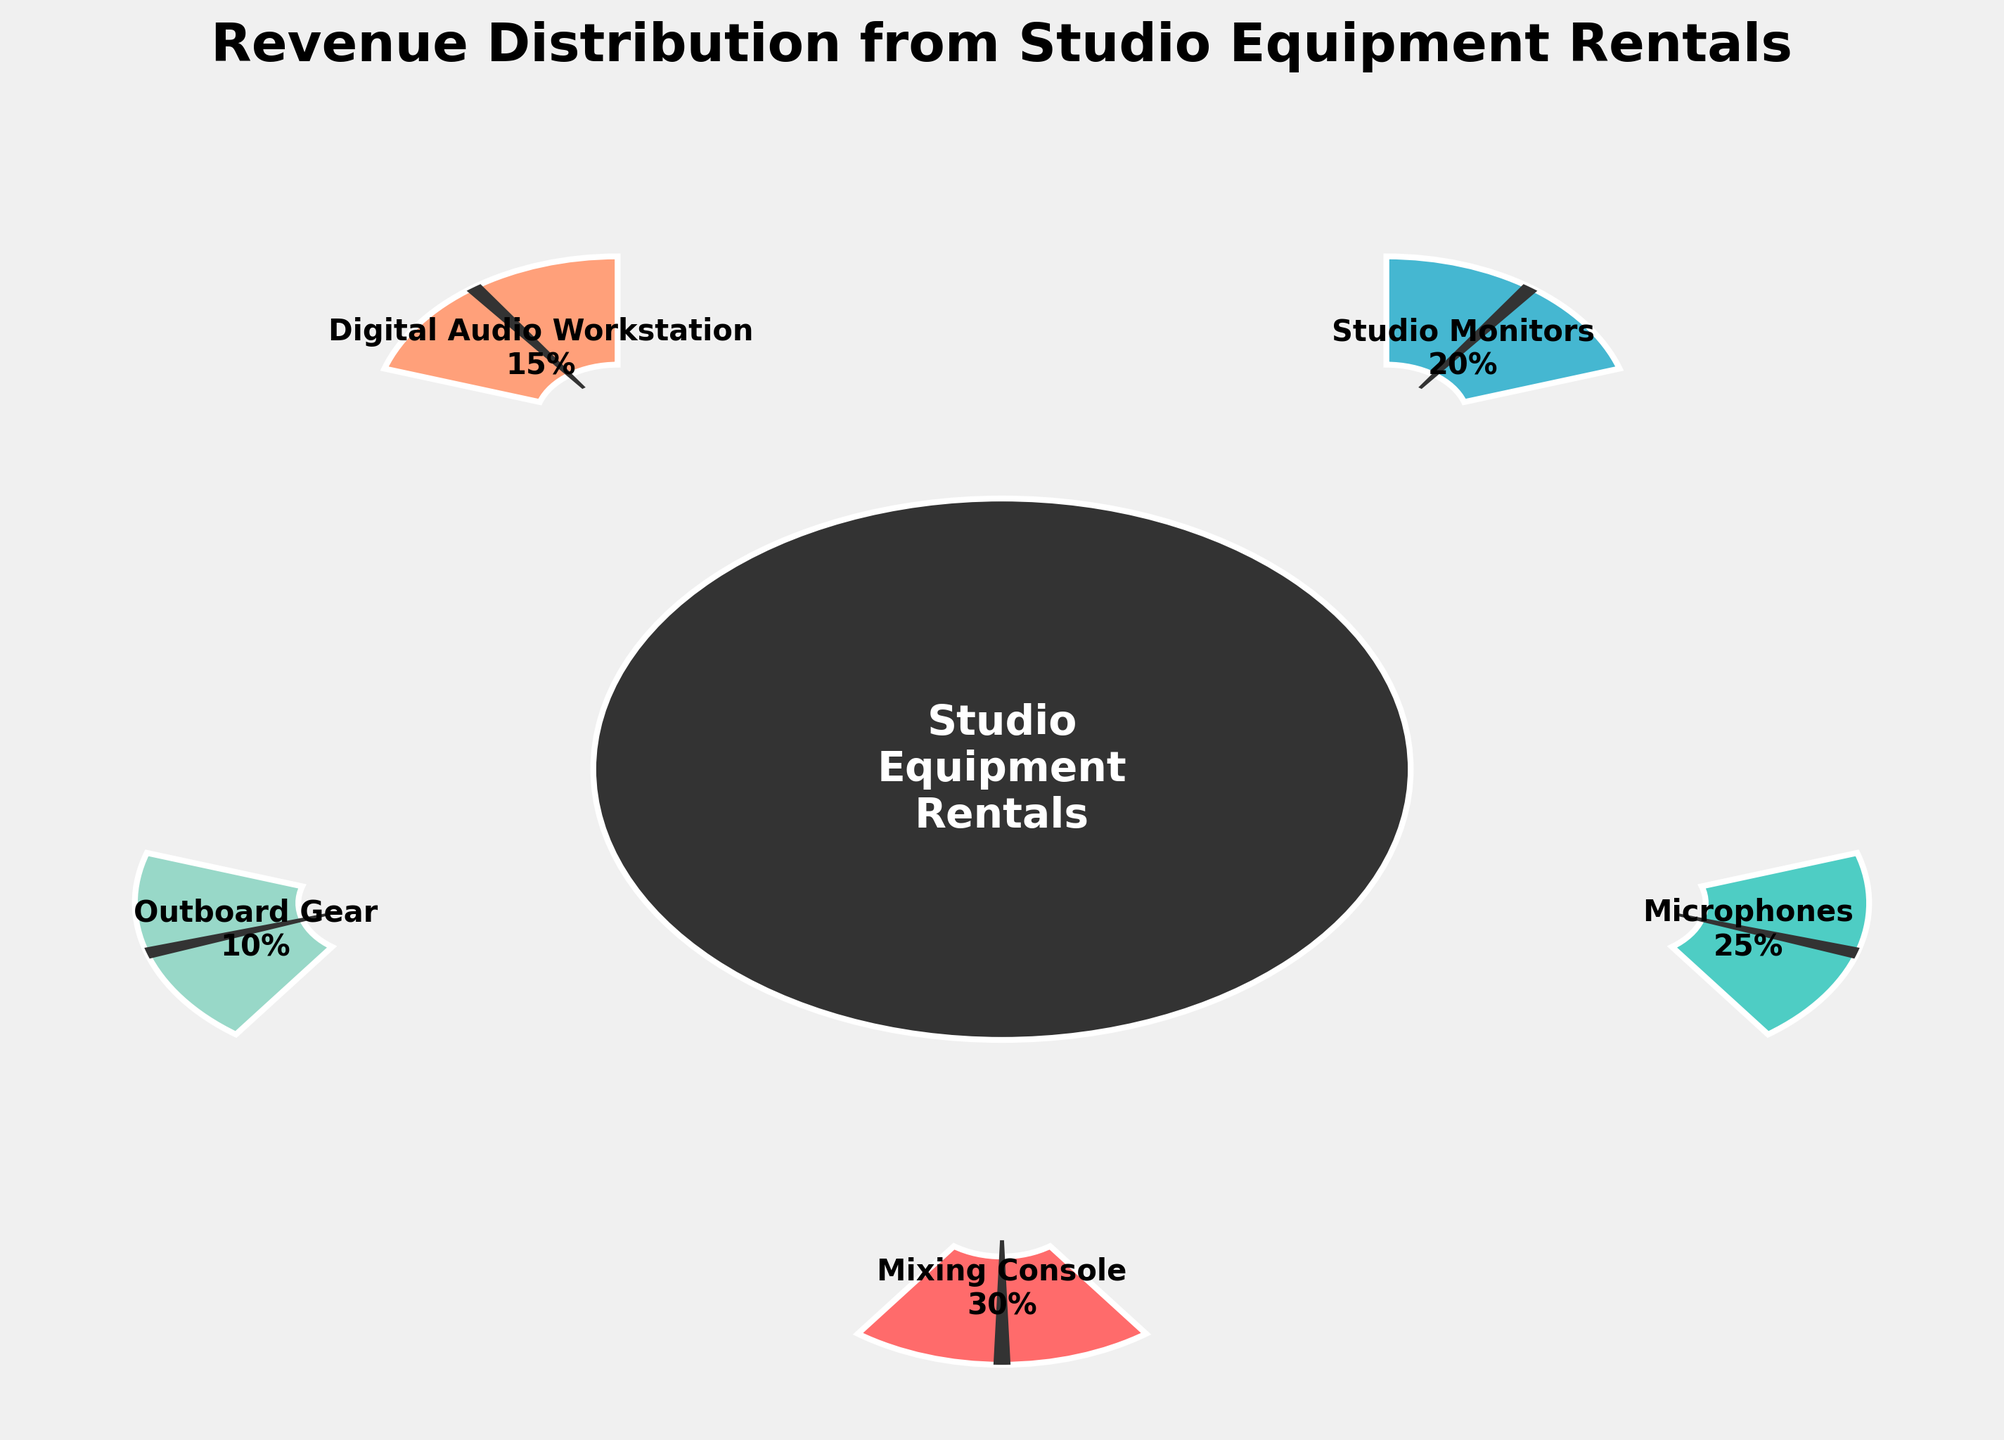What's the title of the figure? The title is located at the top of the figure. It is usually larger and bold to stand out.
Answer: Revenue Distribution from Studio Equipment Rentals What percentage of the revenue comes from Microphones? By looking at the section labeled "Microphones," you can find the percentage within the gauge section.
Answer: 25% Which equipment rental contributes the most to the revenue? Identify the segment with the highest percentage by comparing all labels in the gauge chart.
Answer: Mixing Console How much higher is the percentage of revenue from Mixing Console rentals compared to Digital Audio Workstation rentals? Mixing Console rentals are 30% and Digital Audio Workstation rentals are 15%. Subtract the latter from the former to find the difference: 30% - 15% = 15%.
Answer: 15% Which equipment contributes the least to the revenue? Identify the segment with the smallest percentage by comparing all labels in the gauge chart.
Answer: Outboard Gear What's the combined percentage of revenue for Studio Monitors and Digital Audio Workstations? Add the percentages for Studio Monitors (20%) and Digital Audio Workstation (15%): 20% + 15% = 35%.
Answer: 35% How many different types of equipment rentals are displayed in the chart? Count the distinct labels and segments in the gauge chart.
Answer: 5 Is the revenue from Microphones rentals greater than from Outboard Gear rentals? Compare the percentages for Microphones (25%) and Outboard Gear (10%).
Answer: Yes How much of the revenue is generated from equipment rentals other than Mixing Console and Microphones? Add the percentages of Studio Monitors (20%), Digital Audio Workstation (15%), and Outboard Gear (10%): 20% + 15% + 10% = 45%.
Answer: 45% What is the average percentage of revenue from all the listed equipment rentals? Add all listed percentages (30% + 25% + 20% + 15% + 10%) and divide by the number of equipment types (5): (30+25+20+15+10)/5 = 20%.
Answer: 20% 